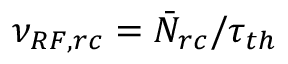<formula> <loc_0><loc_0><loc_500><loc_500>\nu _ { R F , r c } = \bar { N } _ { r c } / \tau _ { t h }</formula> 